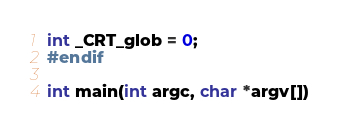Convert code to text. <code><loc_0><loc_0><loc_500><loc_500><_C_>int _CRT_glob = 0;
#endif

int main(int argc, char *argv[])</code> 